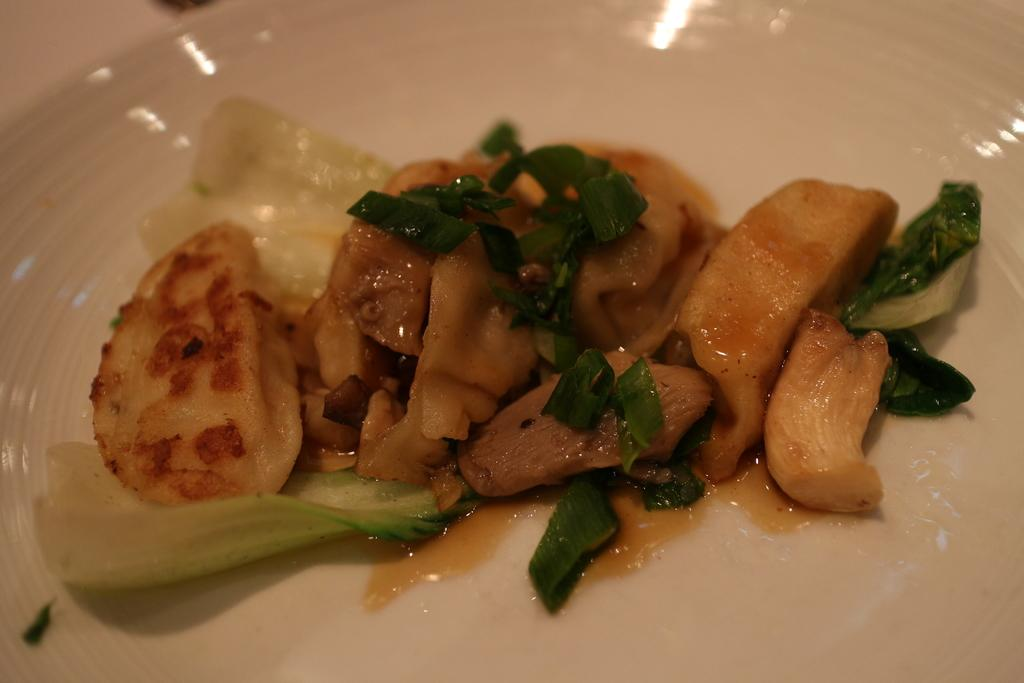What is on the plate that is visible in the image? There is food on a plate in the image. What type of hair can be seen on the plate in the image? There is no hair present on the plate in the image. What type of chess pieces can be seen on the plate in the image? There are no chess pieces present on the plate in the image. What type of acoustics can be heard coming from the plate in the image? There are no sounds or acoustics associated with the plate in the image. 